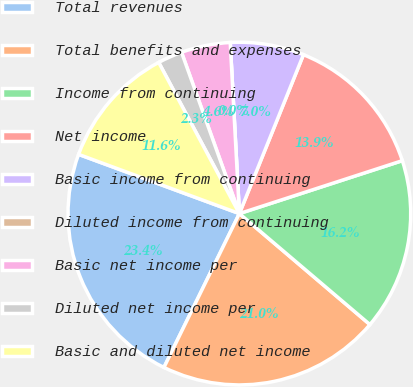<chart> <loc_0><loc_0><loc_500><loc_500><pie_chart><fcel>Total revenues<fcel>Total benefits and expenses<fcel>Income from continuing<fcel>Net income<fcel>Basic income from continuing<fcel>Diluted income from continuing<fcel>Basic net income per<fcel>Diluted net income per<fcel>Basic and diluted net income<nl><fcel>23.36%<fcel>21.04%<fcel>16.21%<fcel>13.9%<fcel>6.95%<fcel>0.0%<fcel>4.63%<fcel>2.32%<fcel>11.58%<nl></chart> 